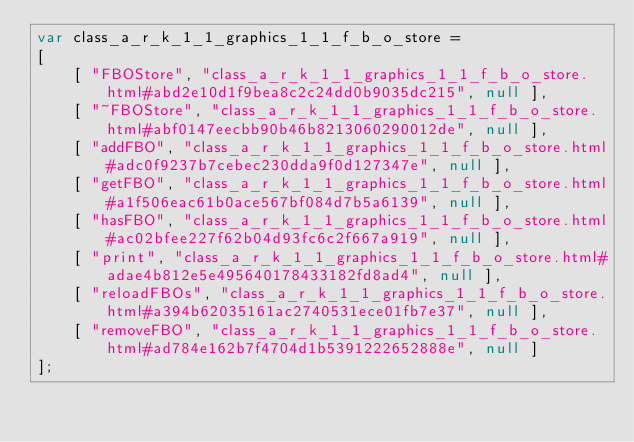Convert code to text. <code><loc_0><loc_0><loc_500><loc_500><_JavaScript_>var class_a_r_k_1_1_graphics_1_1_f_b_o_store =
[
    [ "FBOStore", "class_a_r_k_1_1_graphics_1_1_f_b_o_store.html#abd2e10d1f9bea8c2c24dd0b9035dc215", null ],
    [ "~FBOStore", "class_a_r_k_1_1_graphics_1_1_f_b_o_store.html#abf0147eecbb90b46b8213060290012de", null ],
    [ "addFBO", "class_a_r_k_1_1_graphics_1_1_f_b_o_store.html#adc0f9237b7cebec230dda9f0d127347e", null ],
    [ "getFBO", "class_a_r_k_1_1_graphics_1_1_f_b_o_store.html#a1f506eac61b0ace567bf084d7b5a6139", null ],
    [ "hasFBO", "class_a_r_k_1_1_graphics_1_1_f_b_o_store.html#ac02bfee227f62b04d93fc6c2f667a919", null ],
    [ "print", "class_a_r_k_1_1_graphics_1_1_f_b_o_store.html#adae4b812e5e495640178433182fd8ad4", null ],
    [ "reloadFBOs", "class_a_r_k_1_1_graphics_1_1_f_b_o_store.html#a394b62035161ac2740531ece01fb7e37", null ],
    [ "removeFBO", "class_a_r_k_1_1_graphics_1_1_f_b_o_store.html#ad784e162b7f4704d1b5391222652888e", null ]
];</code> 